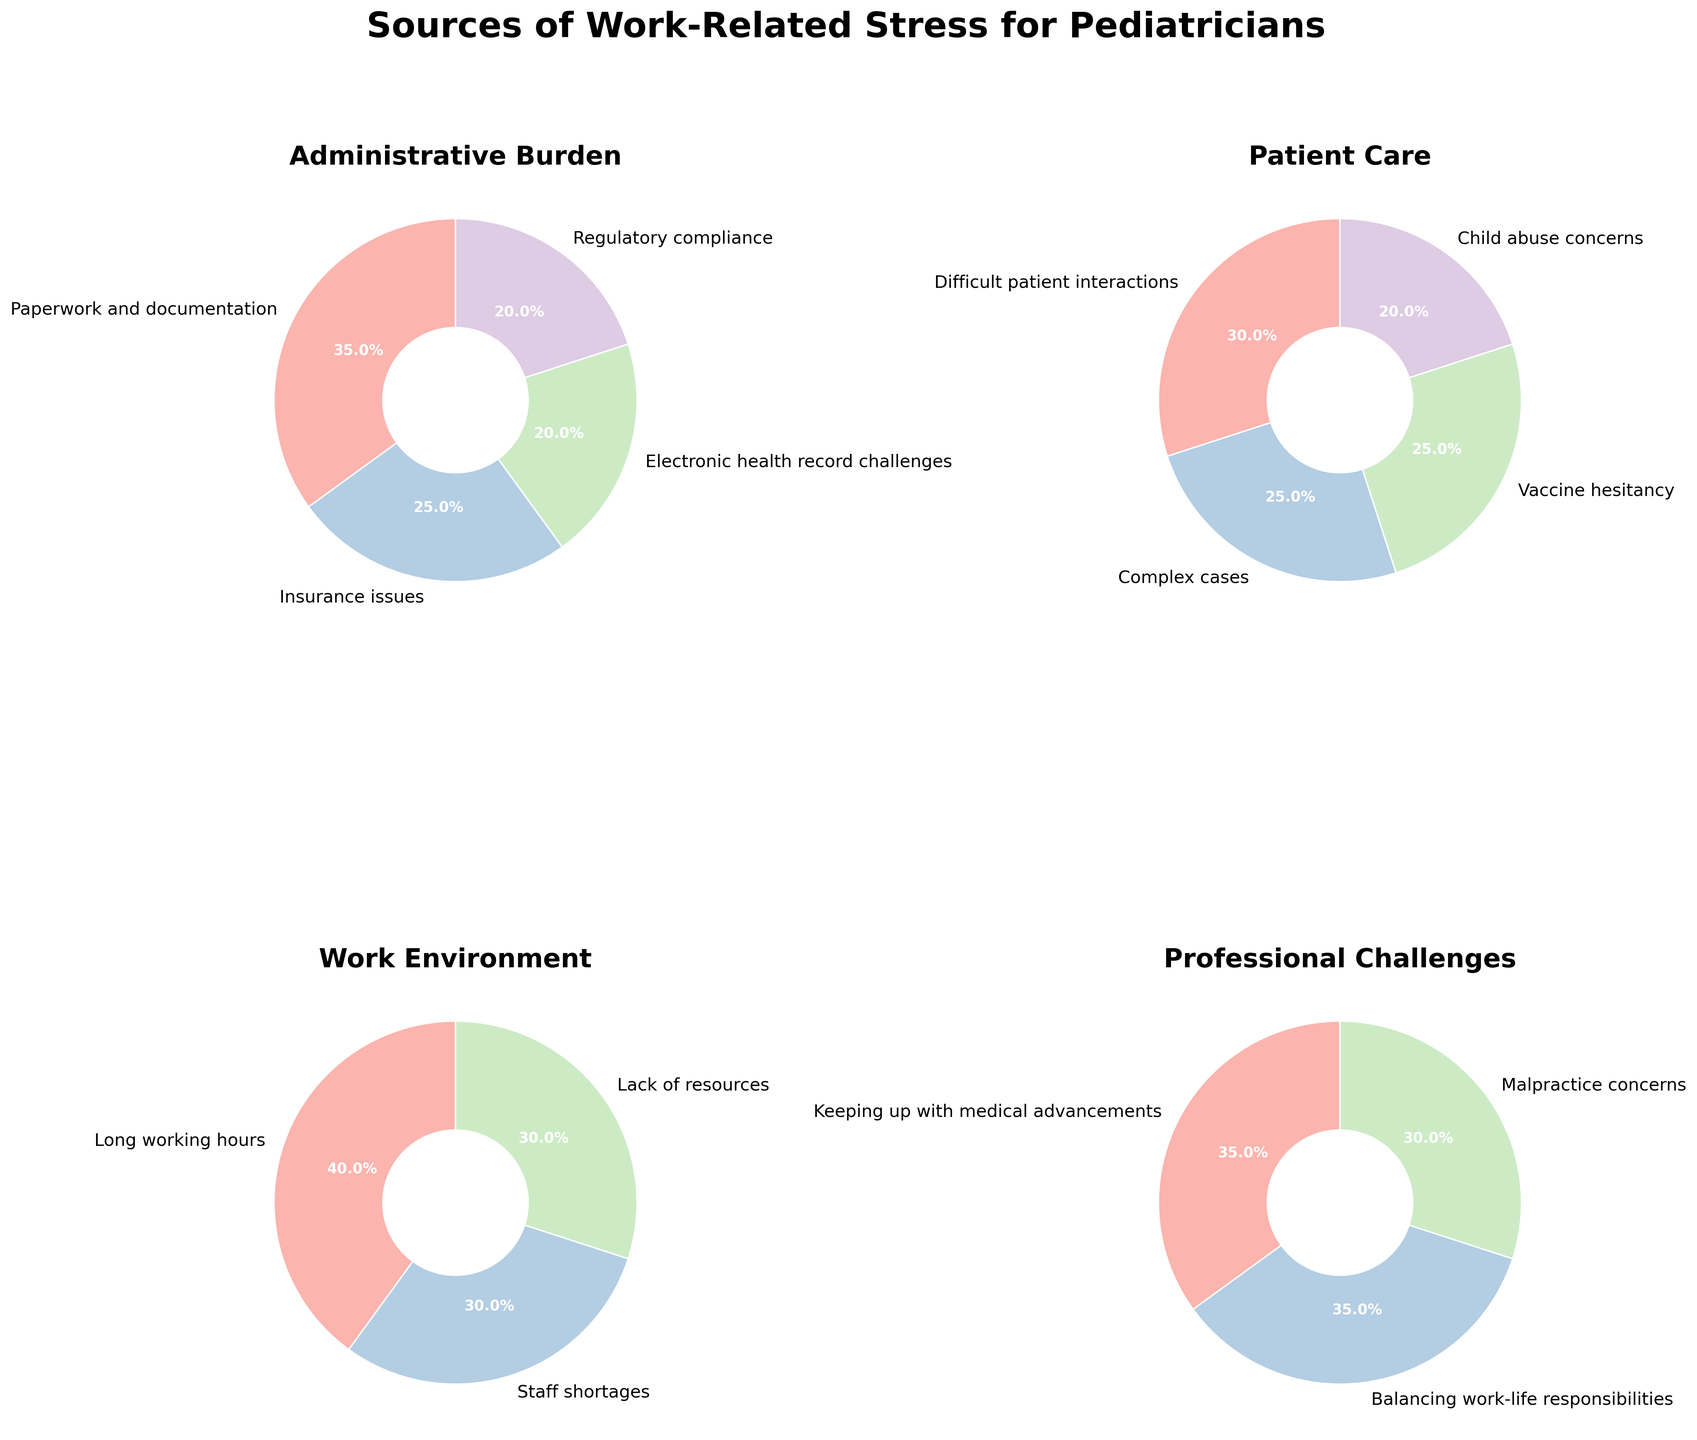What's the highest percentage stress factor in the 'Work Environment' category? The pie chart for 'Work Environment' shows three stress factors: 'Long working hours' (40%), 'Staff shortages' (30%), and 'Lack of resources' (30%). The largest percentage among these is 40% for 'Long working hours'.
Answer: Long working hours (40%) Which category has equal percentages for two stress factors? By looking at the pie charts, 'Work Environment' category shows that 'Staff shortages' and 'Lack of resources' both have a percentage of 30%.
Answer: Work Environment What is the total percentage of stress factors related to Administrative Burden? The pie chart for 'Administrative Burden' shows four stress factors with percentages: 35% + 25% + 20% + 20%. Summing these gives 100%.
Answer: 100% How do the percentages of 'Complex cases' and 'Vaccine hesitancy' compare in the Patient Care category? The 'Patient Care' pie chart lists 'Complex cases' and 'Vaccine hesitancy' both at 25%. Thus, they are equal.
Answer: Equal Which stress factor under Professional Challenges has the highest percentage? The 'Professional Challenges' pie chart shows three stress factors: 'Keeping up with medical advancements' (35%), 'Balancing work-life responsibilities' (35%), 'Malpractice concerns' (30%). The highest percentages are both 'Keeping up with medical advancements' and 'Balancing work-life responsibilities' at 35%.
Answer: Keeping up with medical advancements and Balancing work-life responsibilities What is the percentage difference between 'Paperwork and documentation' and 'Insurance issues' in the Administrative Burden category? The 'Paperwork and documentation' stress factor is 35%, and 'Insurance issues' is 25%. The difference is 35% - 25% = 10%.
Answer: 10% What percentage of stress in the Work Environment is due to 'Long working hours'? The pie chart for 'Work Environment' shows that 'Long working hours' is 40%.
Answer: 40% What is the average percentage of stress factors for Professional Challenges? The percentages for Professional Challenges are 'Keeping up with medical advancements' (35%), 'Balancing work-life responsibilities' (35%), and 'Malpractice concerns' (30%). The average is (35% + 35% + 30%) / 3 = 33.33%.
Answer: 33.33% Which category has the smallest individual stress factor percentage, and what is it? By examining all the pie charts, both 'Administrative Burden' and 'Patient Care' have the smallest stress factor percentages of 20% for 'Electronic health record challenges', 'Regulatory compliance', and 'Child abuse concerns', respectively.
Answer: Administrative Burden and Patient Care (20%) What is the combined percentage of 'Keeping up with medical advancements' and 'Balancing work-life responsibilities' in the Professional Challenges category? These two stress factors are both 35% each in the Professional Challenges pie chart. The combined percentage is 35% + 35% = 70%.
Answer: 70% 